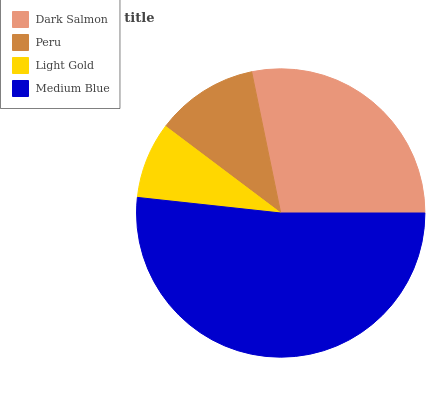Is Light Gold the minimum?
Answer yes or no. Yes. Is Medium Blue the maximum?
Answer yes or no. Yes. Is Peru the minimum?
Answer yes or no. No. Is Peru the maximum?
Answer yes or no. No. Is Dark Salmon greater than Peru?
Answer yes or no. Yes. Is Peru less than Dark Salmon?
Answer yes or no. Yes. Is Peru greater than Dark Salmon?
Answer yes or no. No. Is Dark Salmon less than Peru?
Answer yes or no. No. Is Dark Salmon the high median?
Answer yes or no. Yes. Is Peru the low median?
Answer yes or no. Yes. Is Light Gold the high median?
Answer yes or no. No. Is Dark Salmon the low median?
Answer yes or no. No. 